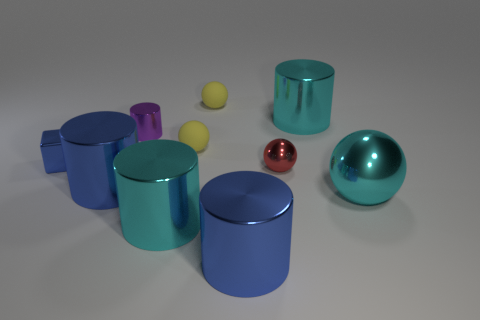What number of small blue cubes are the same material as the large cyan sphere?
Your response must be concise. 1. Is the shape of the cyan object that is behind the small red metallic sphere the same as  the small purple thing?
Give a very brief answer. Yes. The small block that is the same material as the red sphere is what color?
Keep it short and to the point. Blue. There is a small red object that is behind the big blue shiny cylinder that is behind the big cyan shiny sphere; is there a tiny block that is to the left of it?
Make the answer very short. Yes. What is the shape of the red metallic object?
Offer a terse response. Sphere. Are there fewer rubber spheres to the right of the tiny red thing than big red matte spheres?
Make the answer very short. No. Is there a small blue thing that has the same shape as the tiny purple object?
Ensure brevity in your answer.  No. What shape is the blue object that is the same size as the red metal sphere?
Offer a terse response. Cube. How many objects are either green rubber spheres or cyan shiny spheres?
Your answer should be compact. 1. Are there any large yellow metallic cylinders?
Offer a very short reply. No. 